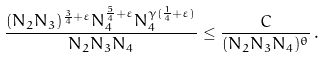<formula> <loc_0><loc_0><loc_500><loc_500>\frac { ( N _ { 2 } N _ { 3 } ) ^ { \frac { 3 } { 4 } + \varepsilon } N _ { 4 } ^ { \frac { 5 } { 4 } + \varepsilon } N _ { 4 } ^ { \gamma ( \frac { 1 } { 4 } + \varepsilon ) } } { N _ { 2 } N _ { 3 } N _ { 4 } } \leq \frac { C } { ( N _ { 2 } N _ { 3 } N _ { 4 } ) ^ { \theta } } \, .</formula> 